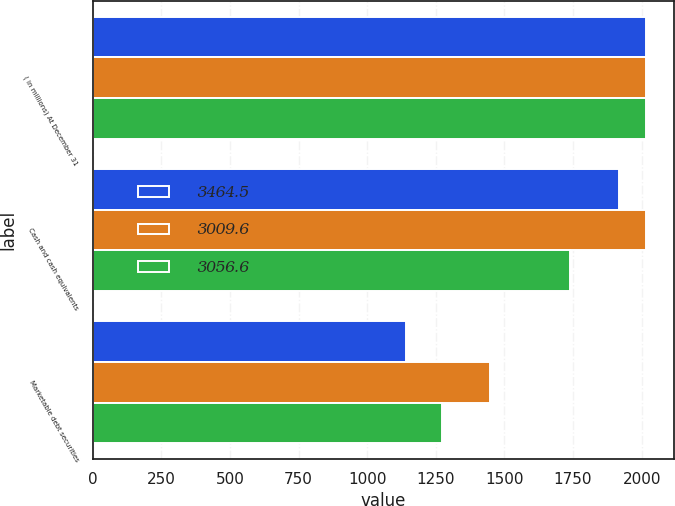Convert chart to OTSL. <chart><loc_0><loc_0><loc_500><loc_500><stacked_bar_chart><ecel><fcel>( in millions) At December 31<fcel>Cash and cash equivalents<fcel>Marketable debt securities<nl><fcel>3464.5<fcel>2016<fcel>1915.7<fcel>1140.9<nl><fcel>3009.6<fcel>2015<fcel>2016.4<fcel>1448.1<nl><fcel>3056.6<fcel>2014<fcel>1737.6<fcel>1272<nl></chart> 